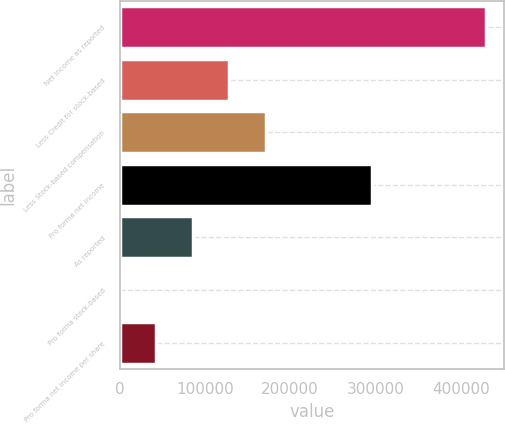Convert chart. <chart><loc_0><loc_0><loc_500><loc_500><bar_chart><fcel>Net income as reported<fcel>Less Credit for stock-based<fcel>Less Stock-based compensation<fcel>Pro forma net income<fcel>As reported<fcel>Pro forma stock-based<fcel>Pro forma net income per share<nl><fcel>428978<fcel>128694<fcel>171592<fcel>295590<fcel>85796<fcel>0.52<fcel>42898.3<nl></chart> 